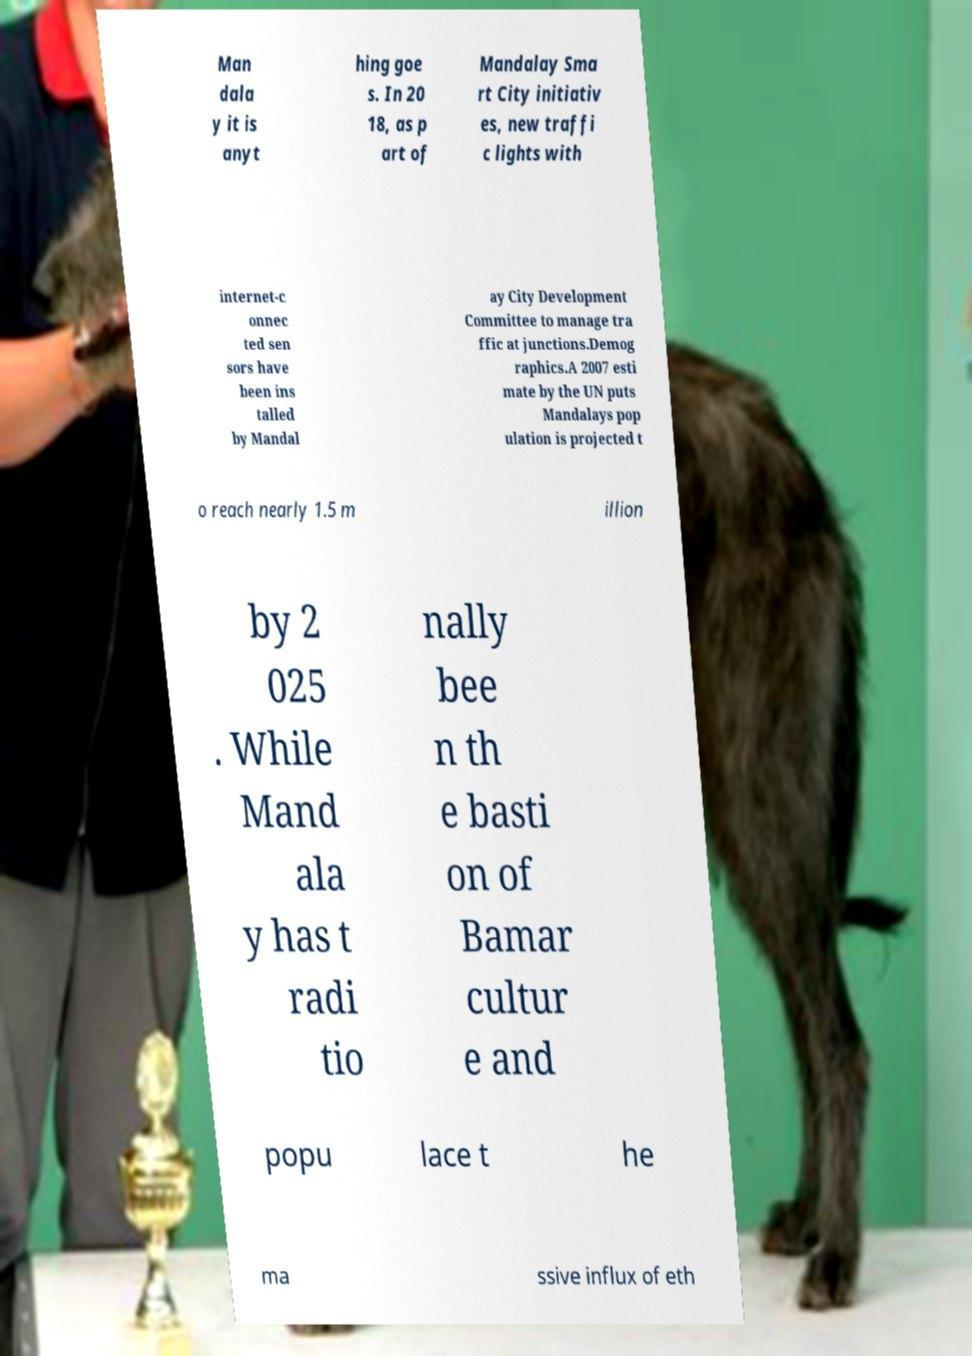I need the written content from this picture converted into text. Can you do that? Man dala y it is anyt hing goe s. In 20 18, as p art of Mandalay Sma rt City initiativ es, new traffi c lights with internet-c onnec ted sen sors have been ins talled by Mandal ay City Development Committee to manage tra ffic at junctions.Demog raphics.A 2007 esti mate by the UN puts Mandalays pop ulation is projected t o reach nearly 1.5 m illion by 2 025 . While Mand ala y has t radi tio nally bee n th e basti on of Bamar cultur e and popu lace t he ma ssive influx of eth 